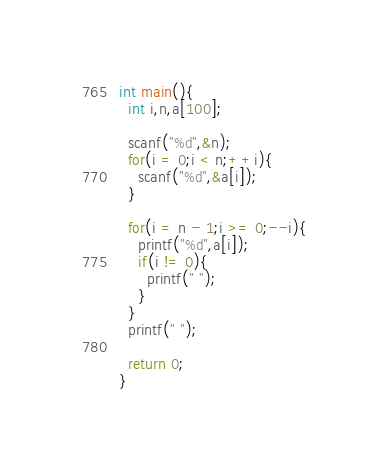<code> <loc_0><loc_0><loc_500><loc_500><_C_>int main(){
  int i,n,a[100];

  scanf("%d",&n);
  for(i = 0;i < n;++i){
    scanf("%d",&a[i]);
  }

  for(i = n - 1;i >= 0;--i){
    printf("%d",a[i]);
    if(i != 0){
      printf(" ");
    }
  }
  printf(" ");

  return 0;
}

</code> 